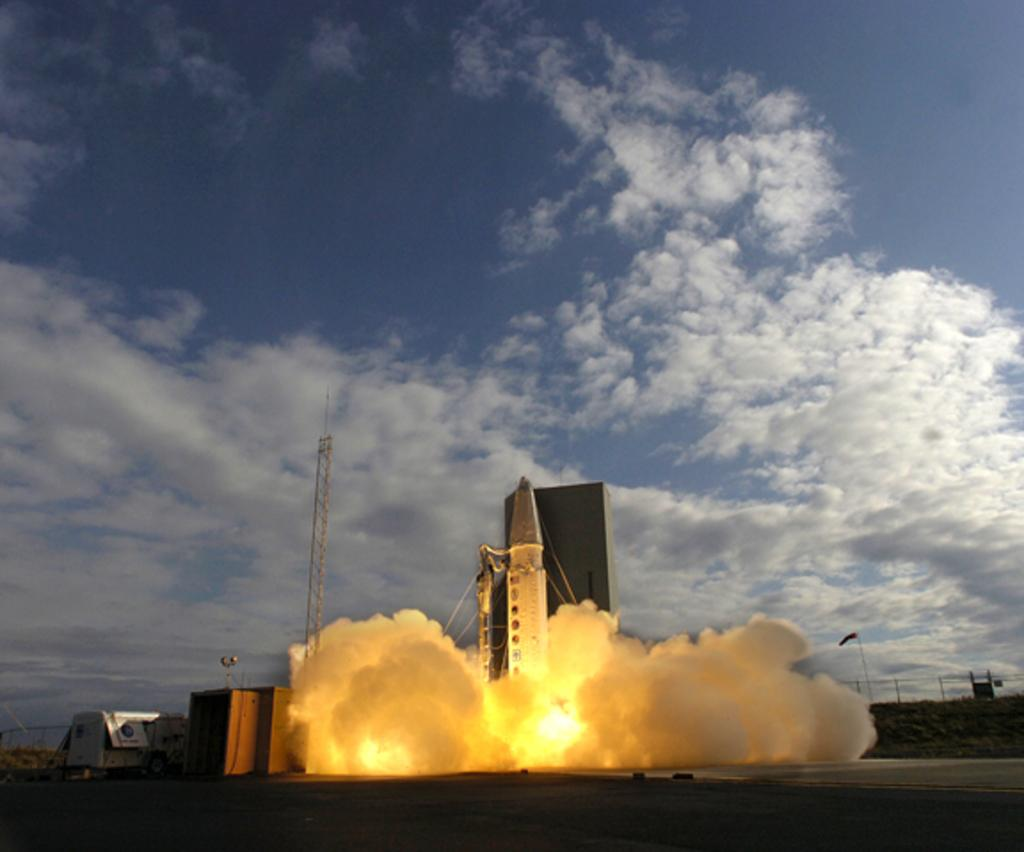What is the main subject of the image? There is a rocket in the image. What other structures or objects can be seen in the image? There is a tower in the image. What is happening to the rocket in the image? There is fire and smoke in the image, suggesting that the rocket is launching. What is visible on the ground in the image? There are objects on the ground in the image. What type of barrier is present in the image? There is fencing in the image. What is visible in the sky in the image? There are clouds in the sky in the image. What type of ornament is hanging from the rocket in the image? There is no ornament hanging from the rocket in the image; it is launching with fire and smoke. What is the title of the image? The image does not have a title; it is a visual representation of a rocket launch. 